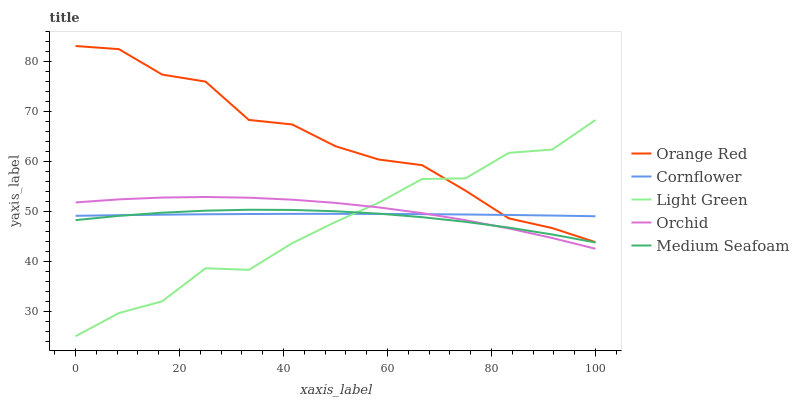Does Light Green have the minimum area under the curve?
Answer yes or no. Yes. Does Orange Red have the maximum area under the curve?
Answer yes or no. Yes. Does Medium Seafoam have the minimum area under the curve?
Answer yes or no. No. Does Medium Seafoam have the maximum area under the curve?
Answer yes or no. No. Is Cornflower the smoothest?
Answer yes or no. Yes. Is Light Green the roughest?
Answer yes or no. Yes. Is Medium Seafoam the smoothest?
Answer yes or no. No. Is Medium Seafoam the roughest?
Answer yes or no. No. Does Medium Seafoam have the lowest value?
Answer yes or no. No. Does Orange Red have the highest value?
Answer yes or no. Yes. Does Medium Seafoam have the highest value?
Answer yes or no. No. Is Medium Seafoam less than Orange Red?
Answer yes or no. Yes. Is Orange Red greater than Orchid?
Answer yes or no. Yes. Does Medium Seafoam intersect Cornflower?
Answer yes or no. Yes. Is Medium Seafoam less than Cornflower?
Answer yes or no. No. Is Medium Seafoam greater than Cornflower?
Answer yes or no. No. Does Medium Seafoam intersect Orange Red?
Answer yes or no. No. 